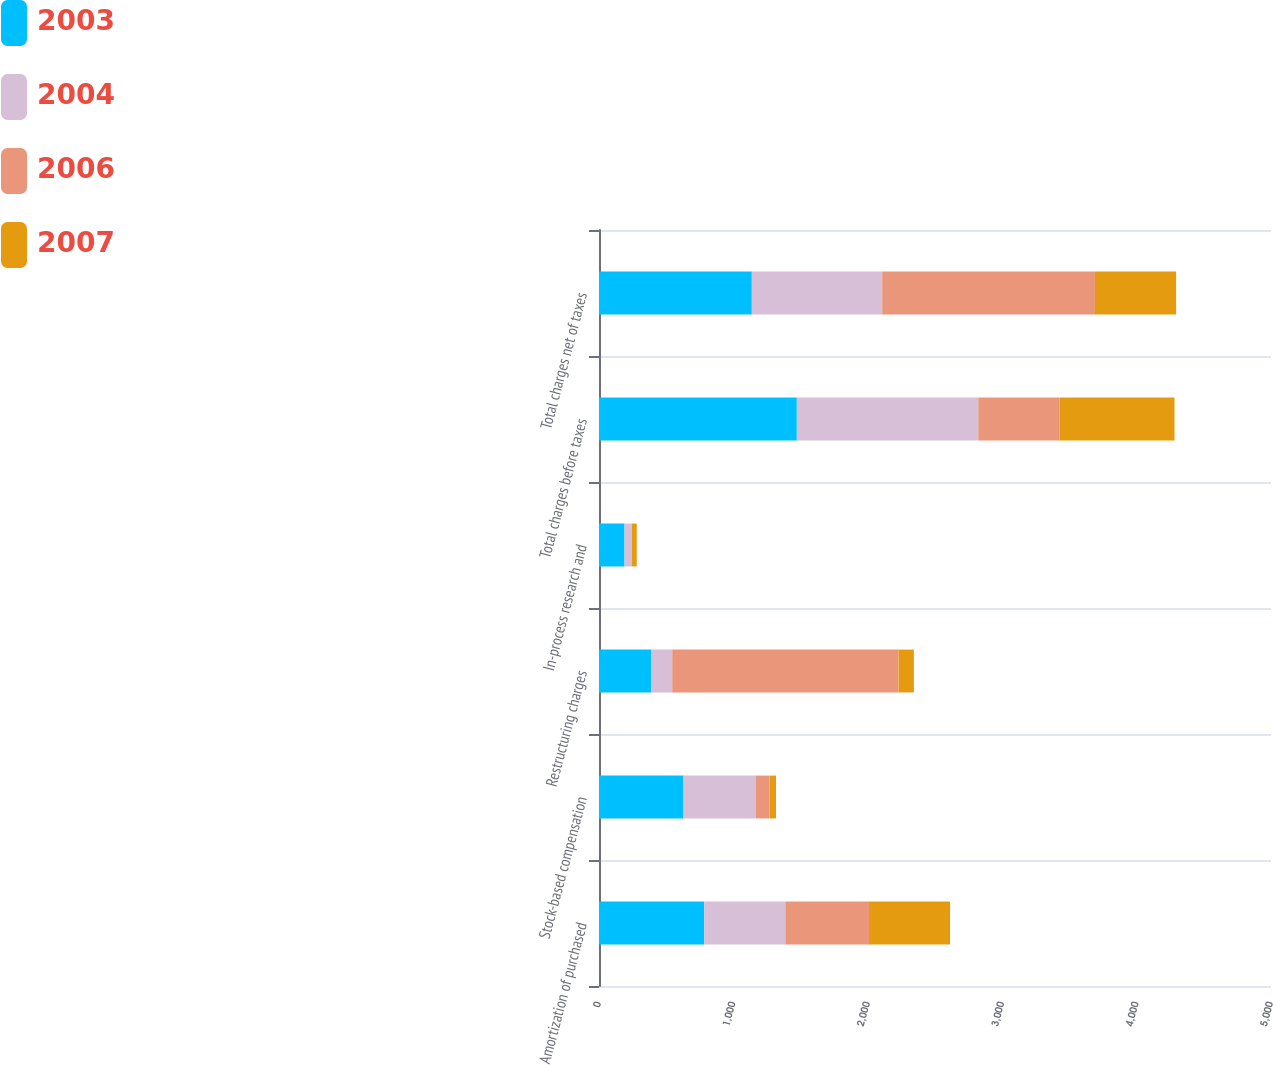Convert chart. <chart><loc_0><loc_0><loc_500><loc_500><stacked_bar_chart><ecel><fcel>Amortization of purchased<fcel>Stock-based compensation<fcel>Restructuring charges<fcel>In-process research and<fcel>Total charges before taxes<fcel>Total charges net of taxes<nl><fcel>2003<fcel>783<fcel>629<fcel>387<fcel>190<fcel>1472<fcel>1137<nl><fcel>2004<fcel>604<fcel>536<fcel>158<fcel>52<fcel>1350<fcel>970<nl><fcel>2006<fcel>622<fcel>104<fcel>1684<fcel>2<fcel>604<fcel>1583<nl><fcel>2007<fcel>603<fcel>48<fcel>114<fcel>37<fcel>856<fcel>604<nl></chart> 